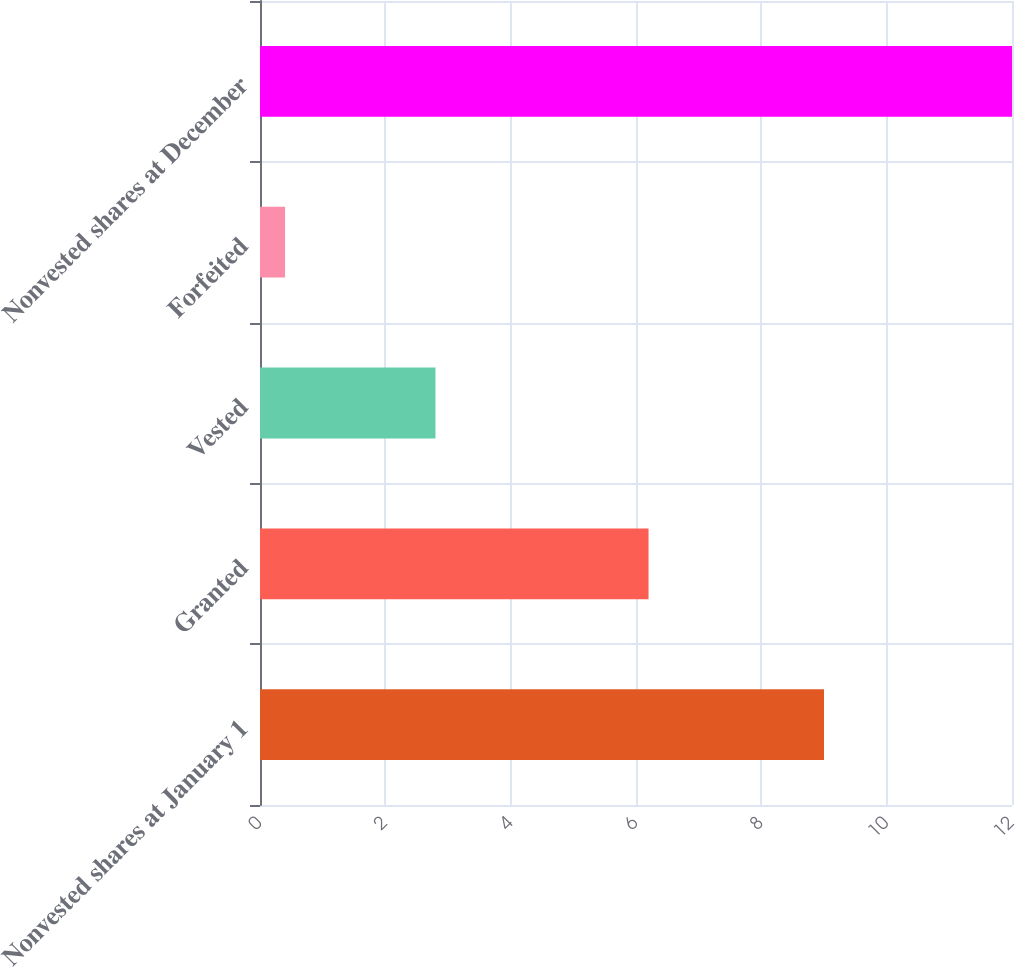Convert chart. <chart><loc_0><loc_0><loc_500><loc_500><bar_chart><fcel>Nonvested shares at January 1<fcel>Granted<fcel>Vested<fcel>Forfeited<fcel>Nonvested shares at December<nl><fcel>9<fcel>6.2<fcel>2.8<fcel>0.4<fcel>12<nl></chart> 